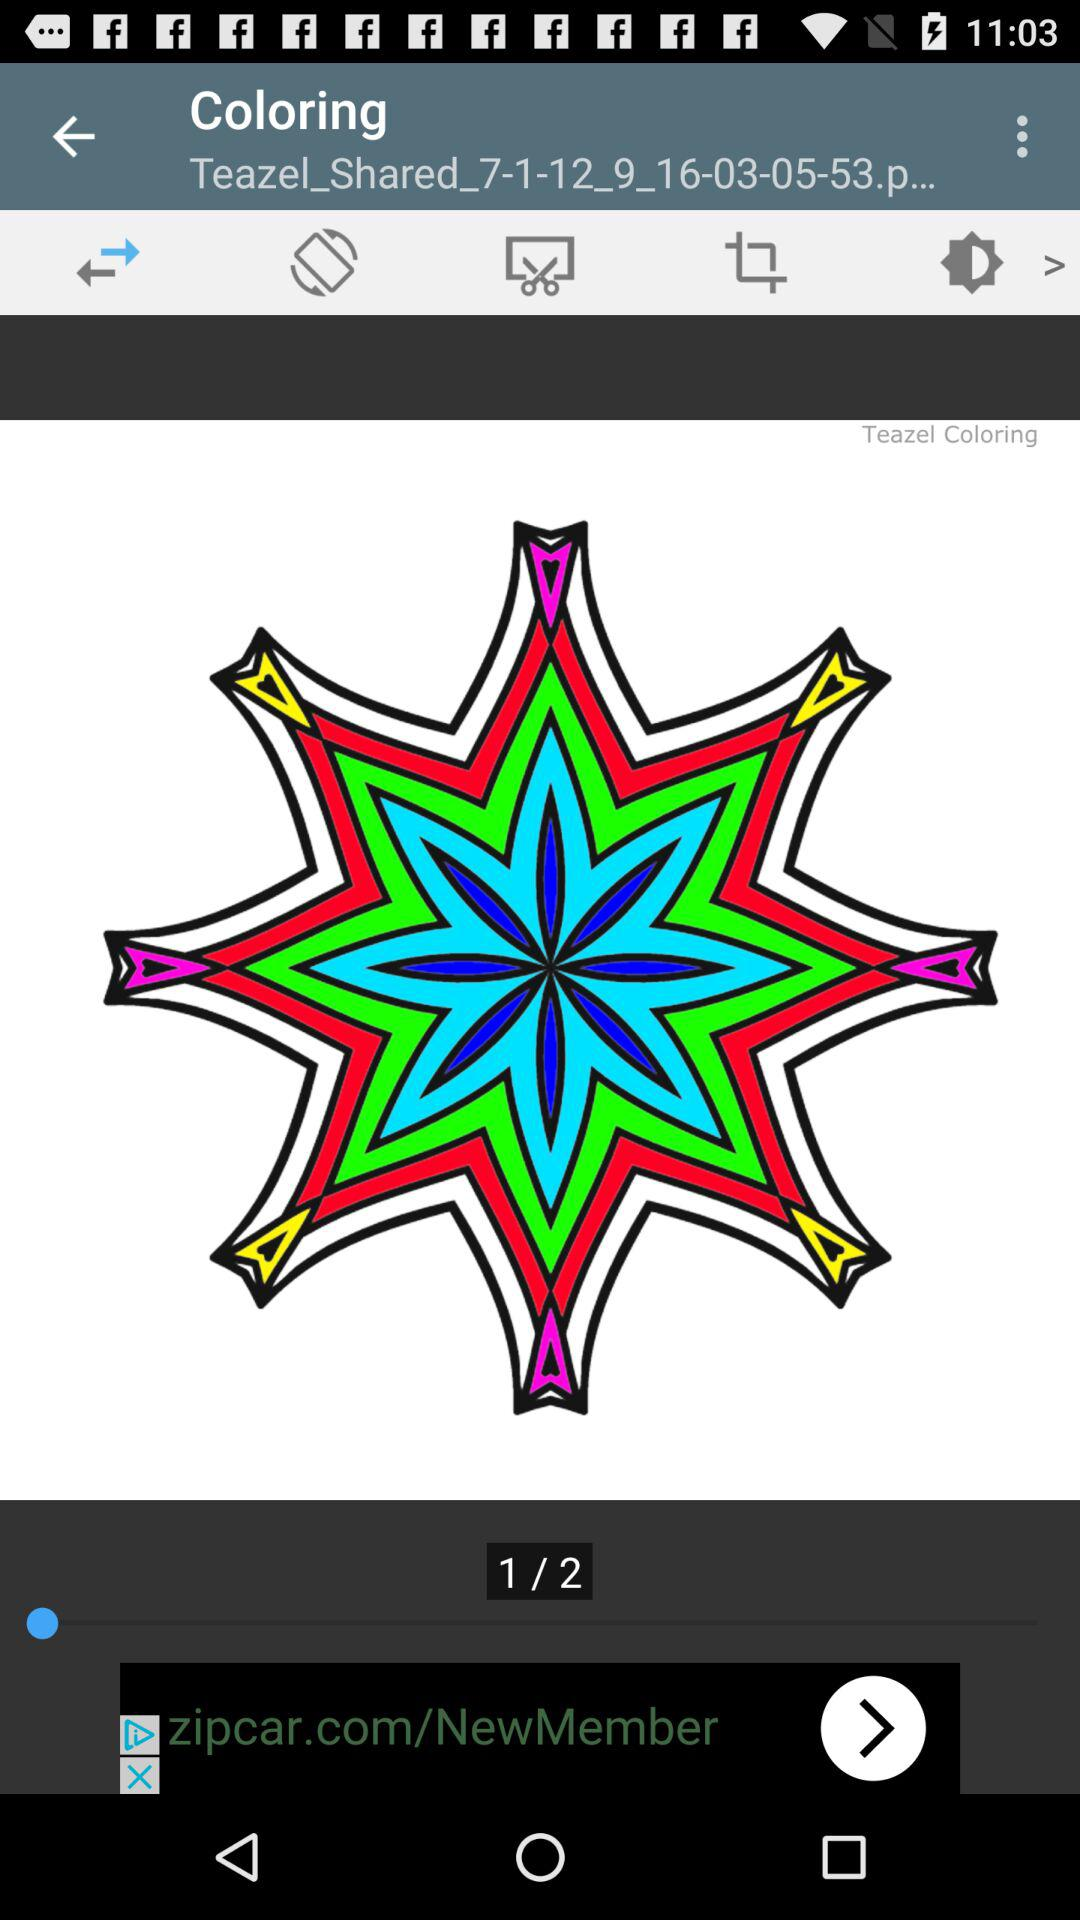How many pages are in the coloring book?
Answer the question using a single word or phrase. 2 